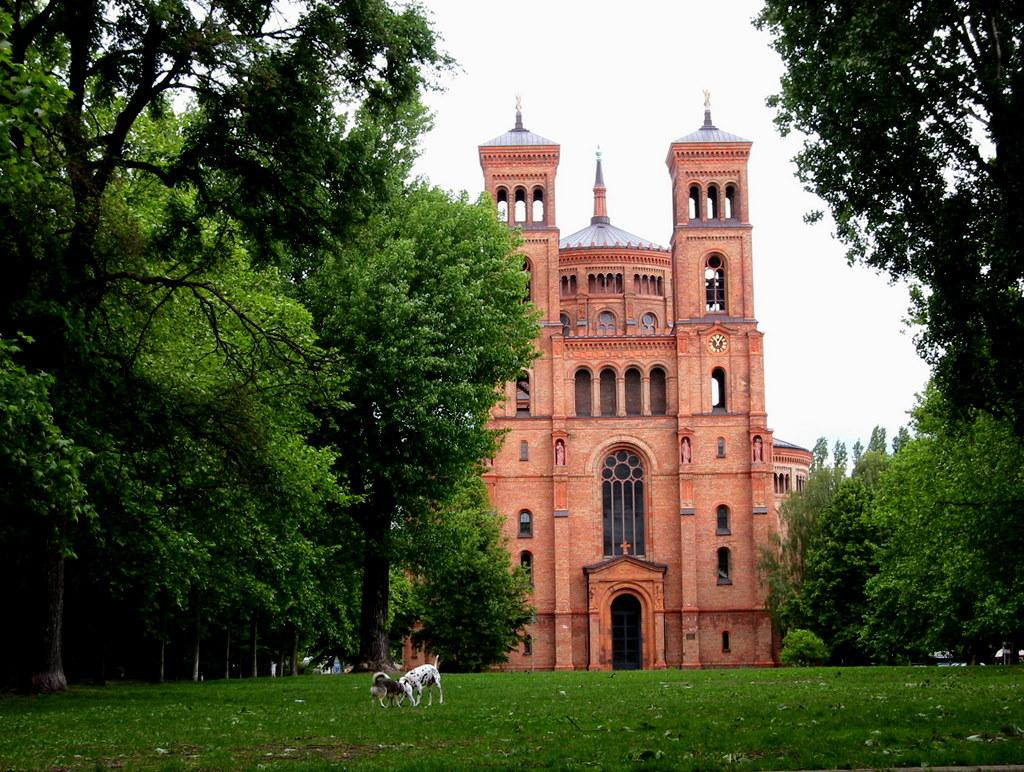How many dogs are present in the image? There are two dogs on the ground in the image. What type of vegetation can be seen on the sides of the image? There are trees on either side of the image. What is visible in the background of the image? There is a building in the background of the image. What is the condition of the sky in the image? The sky is clear in the image. Can you see any wounds on the dogs in the image? There is no indication of any wounds on the dogs in the image. Is there a map or any geographical features visible in the image? There is no map or any geographical features visible in the image; it primarily features the dogs, trees, building, and sky. 